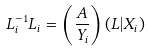<formula> <loc_0><loc_0><loc_500><loc_500>L ^ { - 1 } _ { i } L _ { i } = \left ( \frac { A } { Y _ { i } } \right ) \left ( L | X _ { i } \right )</formula> 